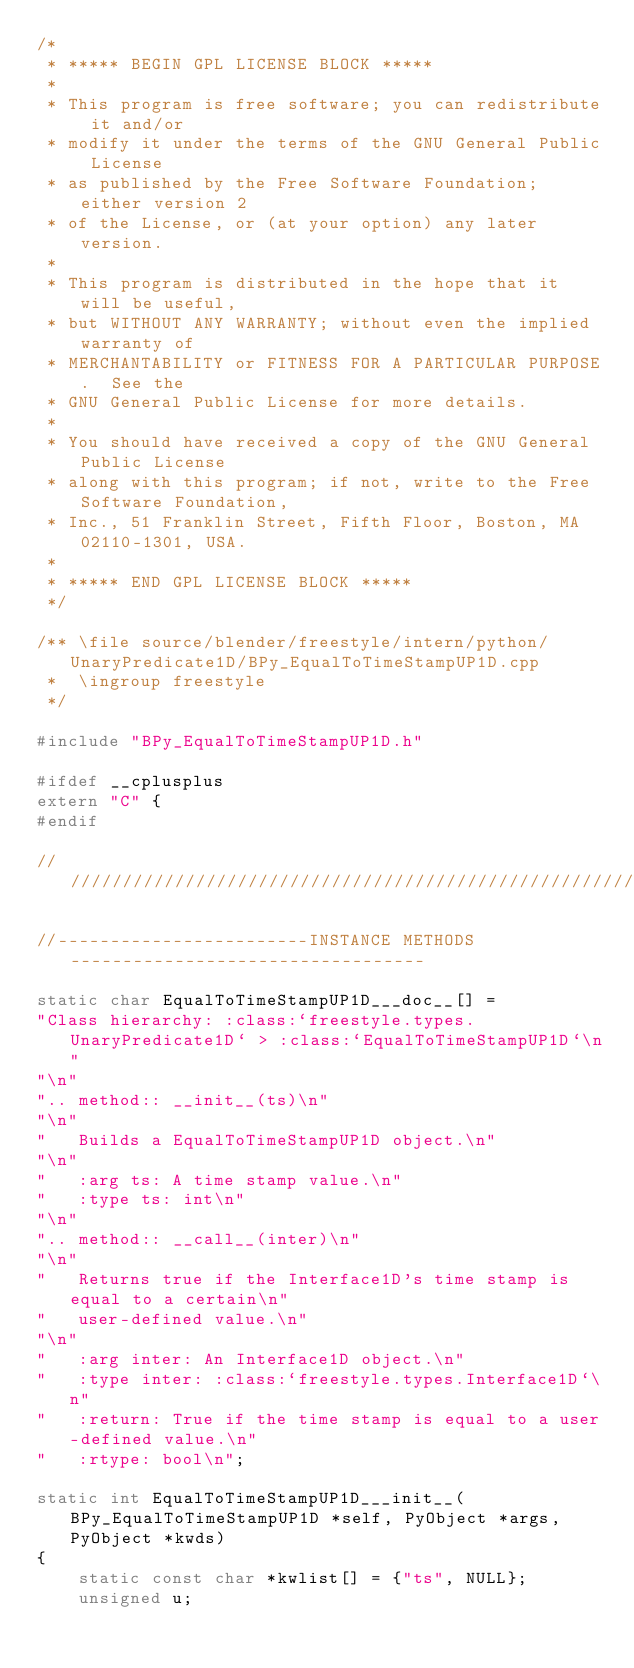<code> <loc_0><loc_0><loc_500><loc_500><_C++_>/*
 * ***** BEGIN GPL LICENSE BLOCK *****
 *
 * This program is free software; you can redistribute it and/or
 * modify it under the terms of the GNU General Public License
 * as published by the Free Software Foundation; either version 2
 * of the License, or (at your option) any later version.
 *
 * This program is distributed in the hope that it will be useful,
 * but WITHOUT ANY WARRANTY; without even the implied warranty of
 * MERCHANTABILITY or FITNESS FOR A PARTICULAR PURPOSE.  See the
 * GNU General Public License for more details.
 *
 * You should have received a copy of the GNU General Public License
 * along with this program; if not, write to the Free Software Foundation,
 * Inc., 51 Franklin Street, Fifth Floor, Boston, MA 02110-1301, USA.
 *
 * ***** END GPL LICENSE BLOCK *****
 */

/** \file source/blender/freestyle/intern/python/UnaryPredicate1D/BPy_EqualToTimeStampUP1D.cpp
 *  \ingroup freestyle
 */

#include "BPy_EqualToTimeStampUP1D.h"

#ifdef __cplusplus
extern "C" {
#endif

///////////////////////////////////////////////////////////////////////////////////////////

//------------------------INSTANCE METHODS ----------------------------------

static char EqualToTimeStampUP1D___doc__[] =
"Class hierarchy: :class:`freestyle.types.UnaryPredicate1D` > :class:`EqualToTimeStampUP1D`\n"
"\n"
".. method:: __init__(ts)\n"
"\n"
"   Builds a EqualToTimeStampUP1D object.\n"
"\n"
"   :arg ts: A time stamp value.\n"
"   :type ts: int\n"
"\n"
".. method:: __call__(inter)\n"
"\n"
"   Returns true if the Interface1D's time stamp is equal to a certain\n"
"   user-defined value.\n"
"\n"
"   :arg inter: An Interface1D object.\n"
"   :type inter: :class:`freestyle.types.Interface1D`\n"
"   :return: True if the time stamp is equal to a user-defined value.\n"
"   :rtype: bool\n";

static int EqualToTimeStampUP1D___init__(BPy_EqualToTimeStampUP1D *self, PyObject *args, PyObject *kwds)
{
	static const char *kwlist[] = {"ts", NULL};
	unsigned u;
</code> 